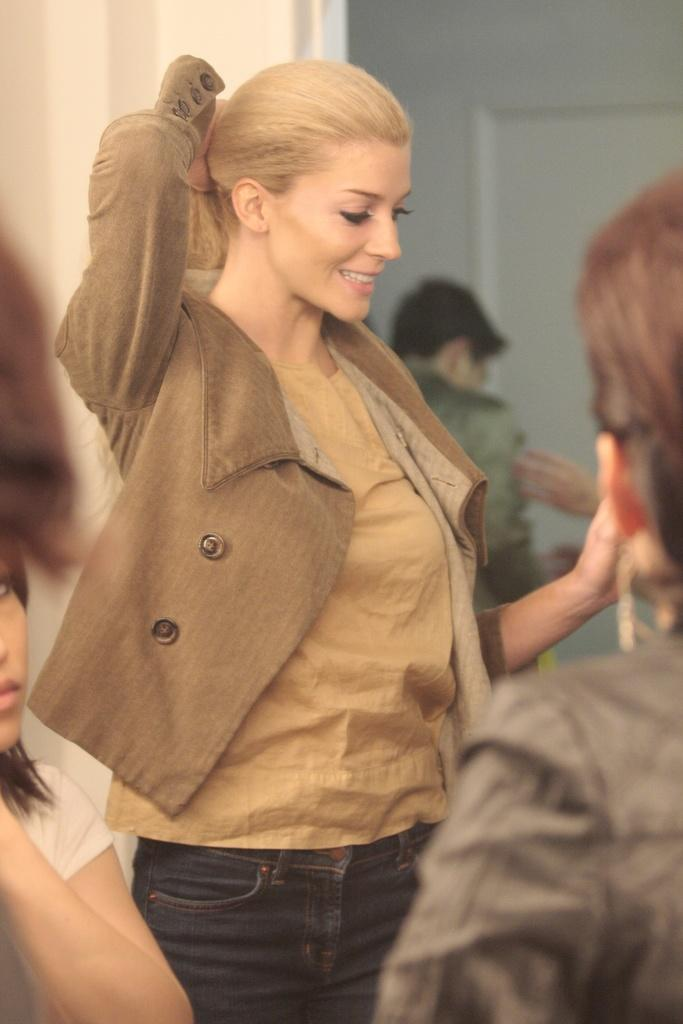Who is present in the image? There is a woman in the image. What is the woman doing in the image? The woman is smiling. Are there any other people in the image? Yes, there are other persons in the image. What can be seen in the background of the image? There is a wall in the background of the image. What holiday is being celebrated in the image? There is no indication of a holiday being celebrated in the image. What is the value of the woman's smile in the image? The value of the woman's smile cannot be quantified, as it is a subjective and emotional expression. 